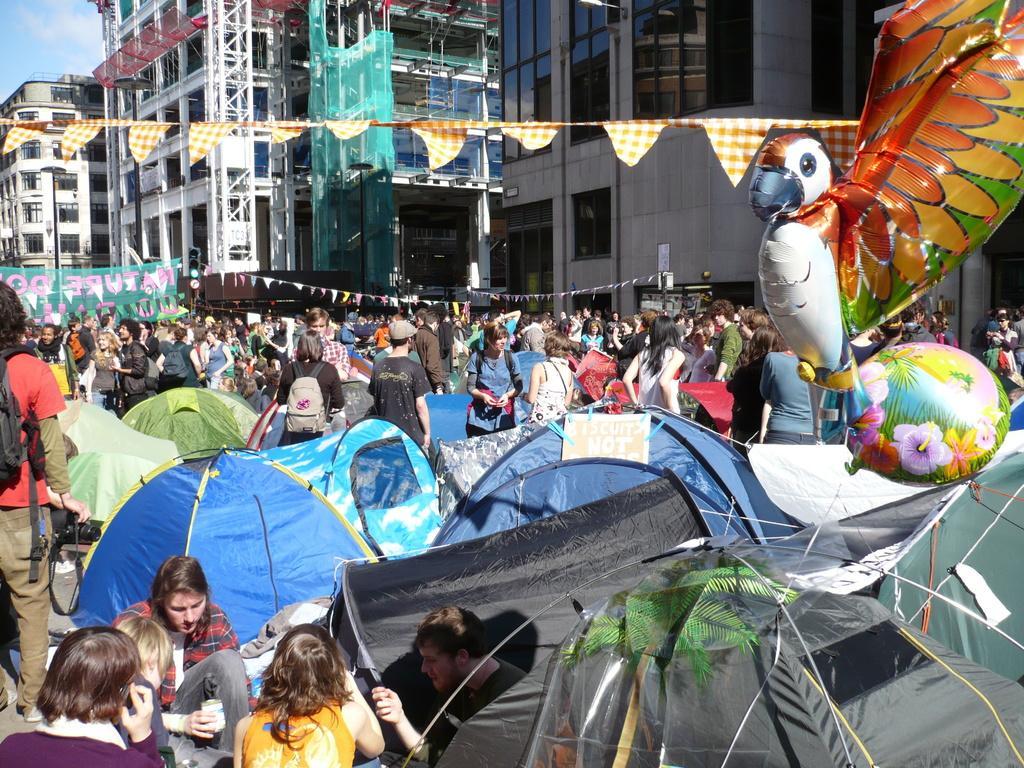In one or two sentences, can you explain what this image depicts? In this image, we can see people standing and sitting and some of them are holding objects in their hands and are wearing bags and we can see some tents, balloons, flags, poles, banners and some boards and there are buildings. At the top, there is sky. 